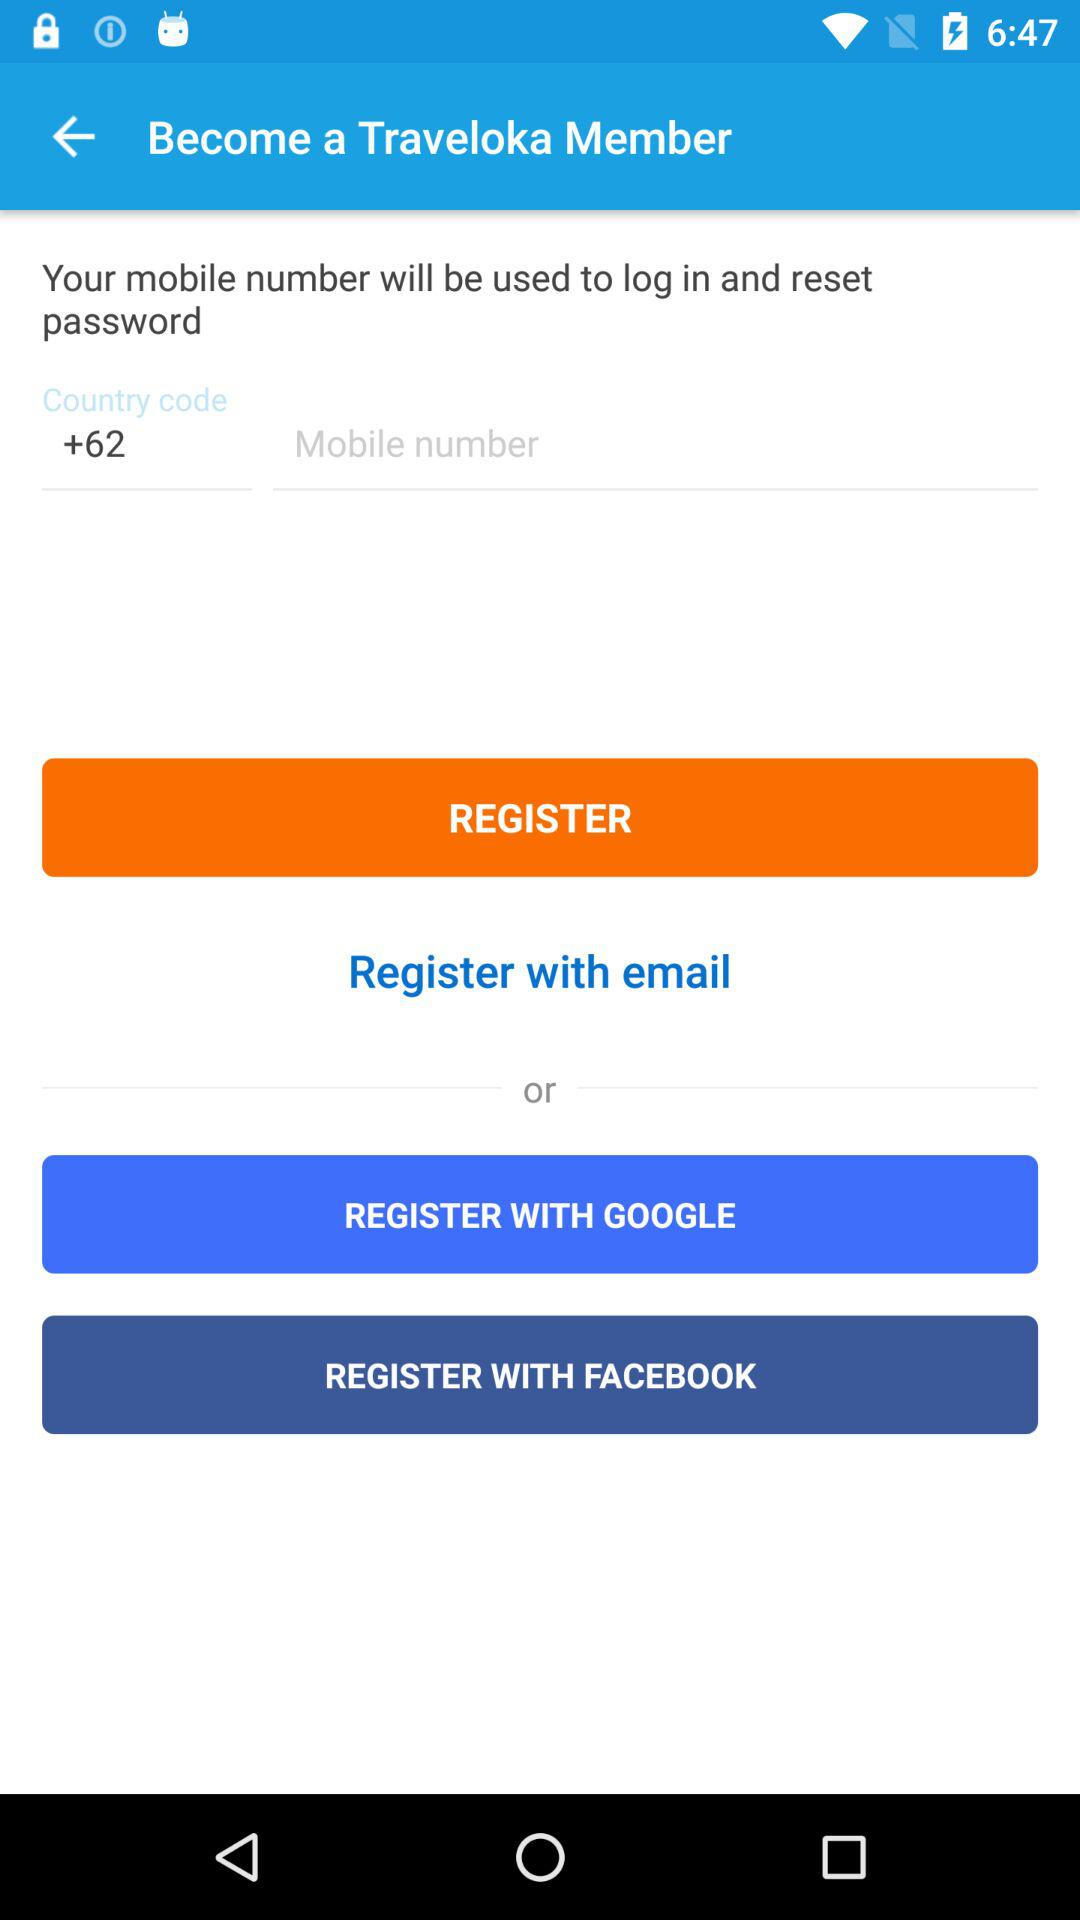What will be used to log in and reset the password? The thing that will be used to log in and reset your password is your mobile number. 